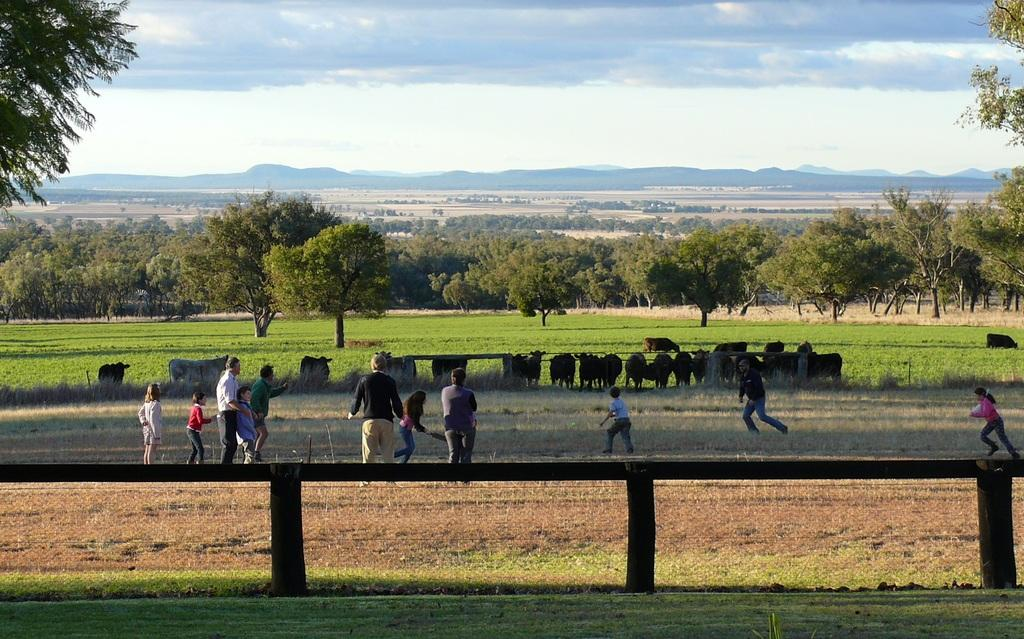What type of natural features can be seen in the image? There are trees and mountains in the image. What living organisms are present in the image? There are animals and people in the image. What are the people doing in the image? Some people are standing, while others are running. What is the color of the sky in the image? The sky is white in color. What type of story is being told by the gate in the image? There is no gate present in the image, so no story can be told by a gate. 